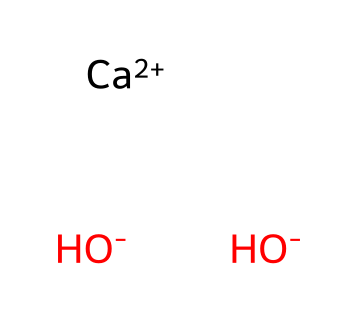What is the formula of this chemical? The chemical structure provided corresponds to calcium hydroxide, denoted as Ca(OH)2. The SMILES notation indicates one calcium ion and two hydroxide ions.
Answer: calcium hydroxide How many hydroxide ions are present? From the SMILES representation, there are two hydroxide ions indicated by [OH-].
Answer: two What type of chemical is calcium hydroxide? Calcium hydroxide is classified as a base due to its ability to accept protons in chemical reactions, making it suitable for neutralizing acids.
Answer: base Which element contributes to the positive charge in this compound? The calcium ion [Ca+2] carries a positive charge, which is characteristic of alkaline earth metals.
Answer: calcium What is the overall charge of calcium hydroxide? The overall charge can be determined by adding the charges of the components: one Ca+2 and two OH-, which gives 0 in total since +2 from Ca balances with -2 from two OH.
Answer: zero What do the hydroxide ions indicate about the properties of this compound? Hydroxide ions (OH-) indicate that calcium hydroxide can increase pH when dissolved in water, showing it as a basic substance.
Answer: basic Why is calcium hydroxide used in antacid tablets? Calcium hydroxide neutralizes stomach acid due to its basic nature, providing relief from heartburn and indigestion by elevating pH.
Answer: neutralization 